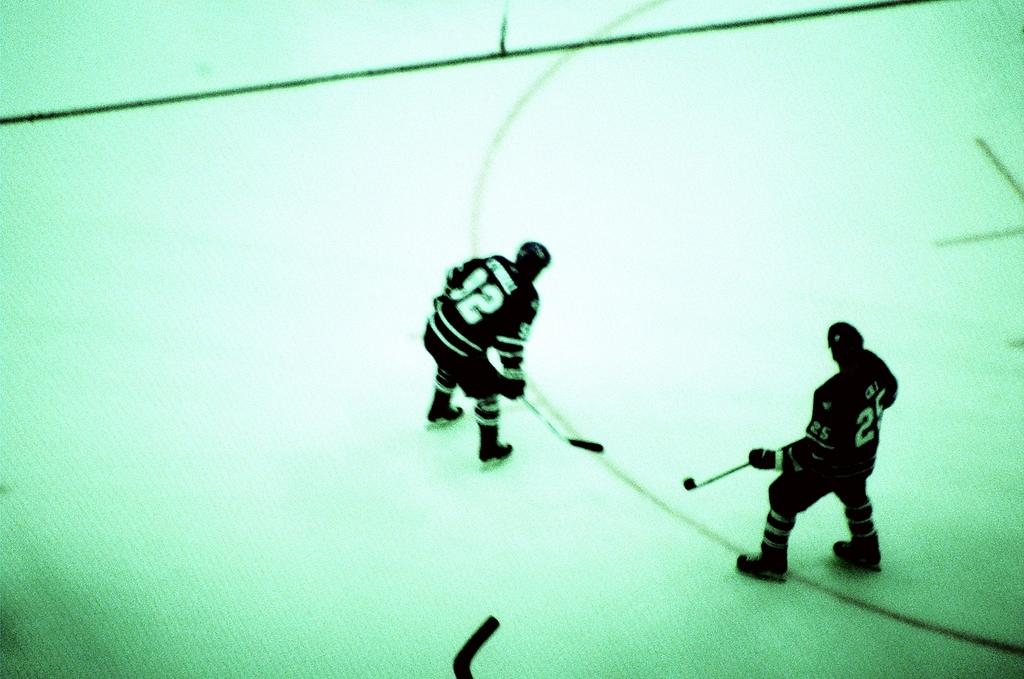How many people are in the image? There are two persons in the image. What activity are the persons engaged in? The persons are playing hockey. How are the persons moving while playing hockey? The persons are skating. What type of surface can be seen in the image? There is a skating ground in the image. What is the topic of the discussion between the two persons in the image? There is no discussion taking place in the image; the persons are playing hockey. How many passengers are visible in the image? There are no passengers present in the image; it features two persons playing hockey on a skating ground. 